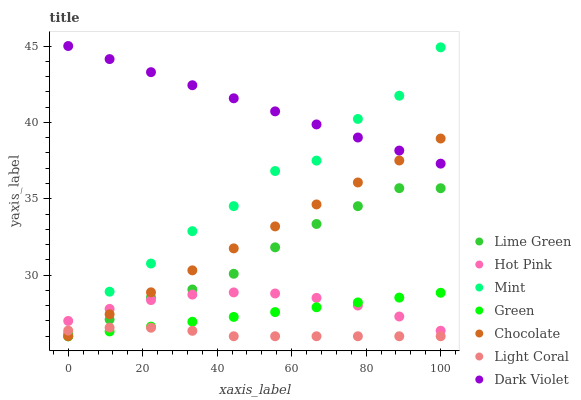Does Light Coral have the minimum area under the curve?
Answer yes or no. Yes. Does Dark Violet have the maximum area under the curve?
Answer yes or no. Yes. Does Hot Pink have the minimum area under the curve?
Answer yes or no. No. Does Hot Pink have the maximum area under the curve?
Answer yes or no. No. Is Green the smoothest?
Answer yes or no. Yes. Is Mint the roughest?
Answer yes or no. Yes. Is Hot Pink the smoothest?
Answer yes or no. No. Is Hot Pink the roughest?
Answer yes or no. No. Does Chocolate have the lowest value?
Answer yes or no. Yes. Does Hot Pink have the lowest value?
Answer yes or no. No. Does Dark Violet have the highest value?
Answer yes or no. Yes. Does Hot Pink have the highest value?
Answer yes or no. No. Is Lime Green less than Dark Violet?
Answer yes or no. Yes. Is Lime Green greater than Green?
Answer yes or no. Yes. Does Chocolate intersect Hot Pink?
Answer yes or no. Yes. Is Chocolate less than Hot Pink?
Answer yes or no. No. Is Chocolate greater than Hot Pink?
Answer yes or no. No. Does Lime Green intersect Dark Violet?
Answer yes or no. No. 